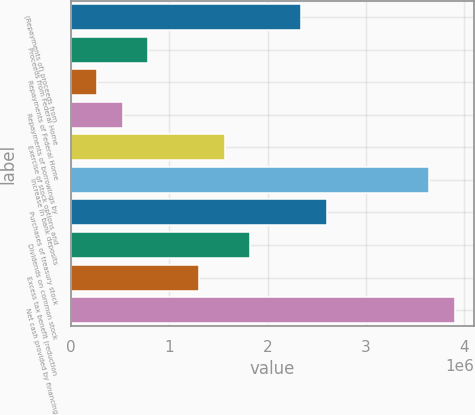Convert chart to OTSL. <chart><loc_0><loc_0><loc_500><loc_500><bar_chart><fcel>(Repayments of) proceeds from<fcel>Proceeds from Federal Home<fcel>Repayments of Federal Home<fcel>Repayments of borrowings by<fcel>Exercise of stock options and<fcel>Increase in bank deposits<fcel>Purchases of treasury stock<fcel>Dividends on common stock<fcel>Excess tax benefit (reduction<fcel>Net cash provided by financing<nl><fcel>2.34127e+06<fcel>782881<fcel>263417<fcel>523149<fcel>1.56208e+06<fcel>3.63993e+06<fcel>2.60101e+06<fcel>1.82181e+06<fcel>1.30235e+06<fcel>3.89967e+06<nl></chart> 